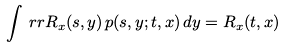<formula> <loc_0><loc_0><loc_500><loc_500>\int _ { \ } r r R _ { x } ( s , y ) \, p ( s , y ; t , x ) \, d y = R _ { x } ( t , x )</formula> 